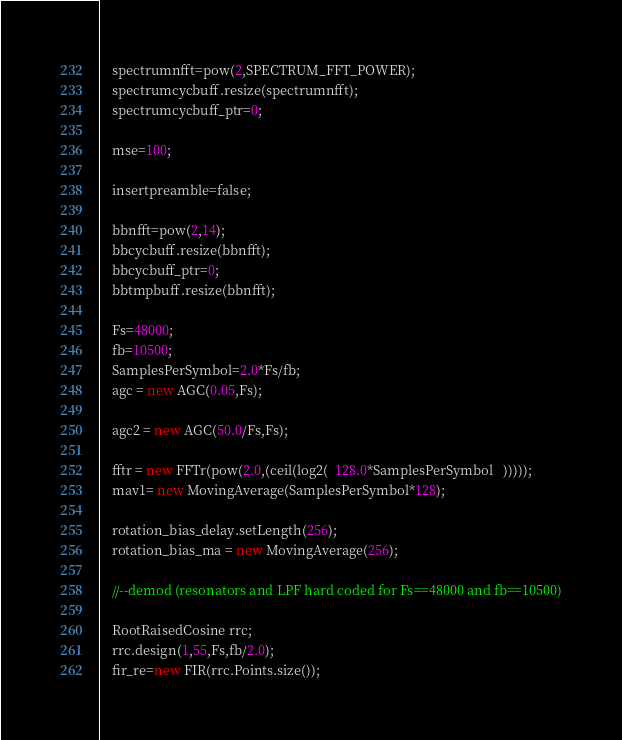<code> <loc_0><loc_0><loc_500><loc_500><_C++_>
    spectrumnfft=pow(2,SPECTRUM_FFT_POWER);
    spectrumcycbuff.resize(spectrumnfft);
    spectrumcycbuff_ptr=0;

    mse=100;

    insertpreamble=false;

    bbnfft=pow(2,14);
    bbcycbuff.resize(bbnfft);
    bbcycbuff_ptr=0;
    bbtmpbuff.resize(bbnfft);

    Fs=48000;
    fb=10500;
    SamplesPerSymbol=2.0*Fs/fb;
    agc = new AGC(0.05,Fs);

    agc2 = new AGC(50.0/Fs,Fs);

    fftr = new FFTr(pow(2.0,(ceil(log2(  128.0*SamplesPerSymbol   )))));
    mav1= new MovingAverage(SamplesPerSymbol*128);

    rotation_bias_delay.setLength(256);
    rotation_bias_ma = new MovingAverage(256);

    //--demod (resonators and LPF hard coded for Fs==48000 and fb==10500)

    RootRaisedCosine rrc;
    rrc.design(1,55,Fs,fb/2.0);
    fir_re=new FIR(rrc.Points.size());</code> 